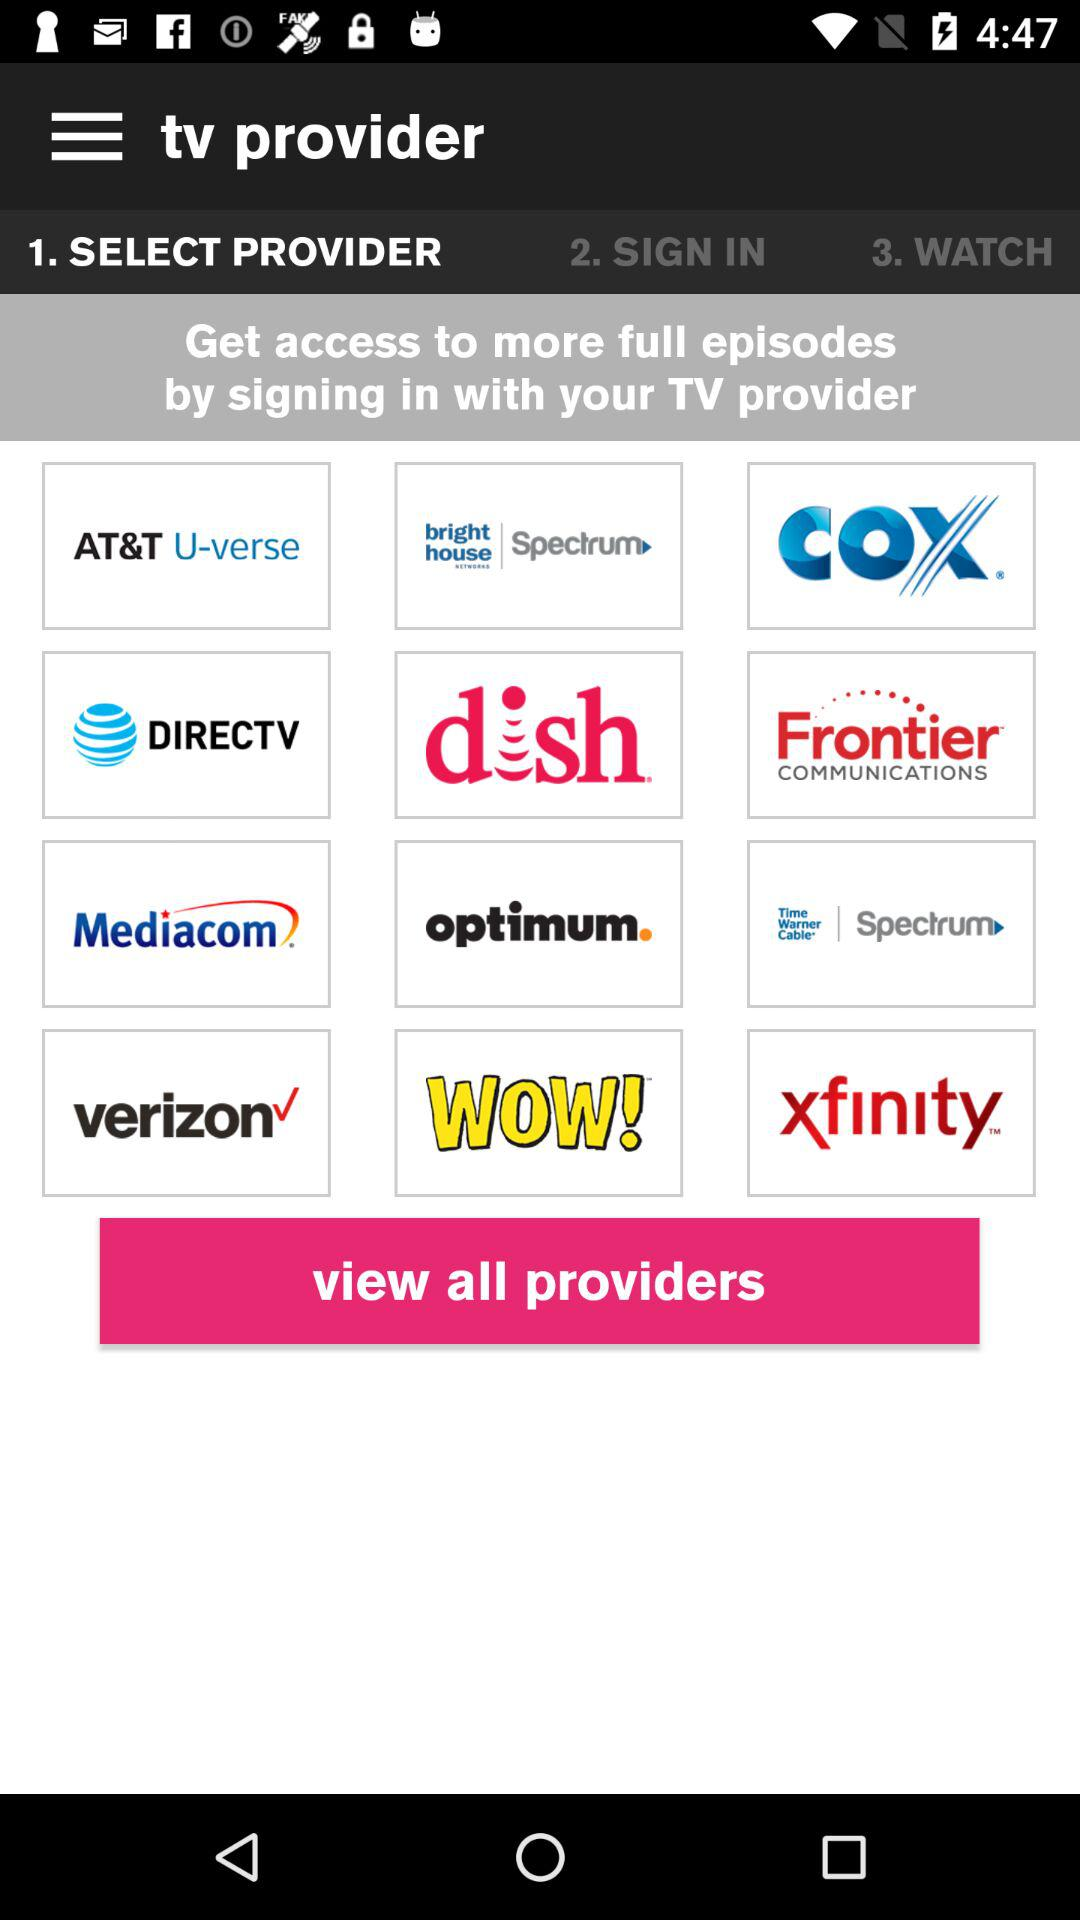Which tab is selected? The selected tab is "SELECT PROVIDER". 